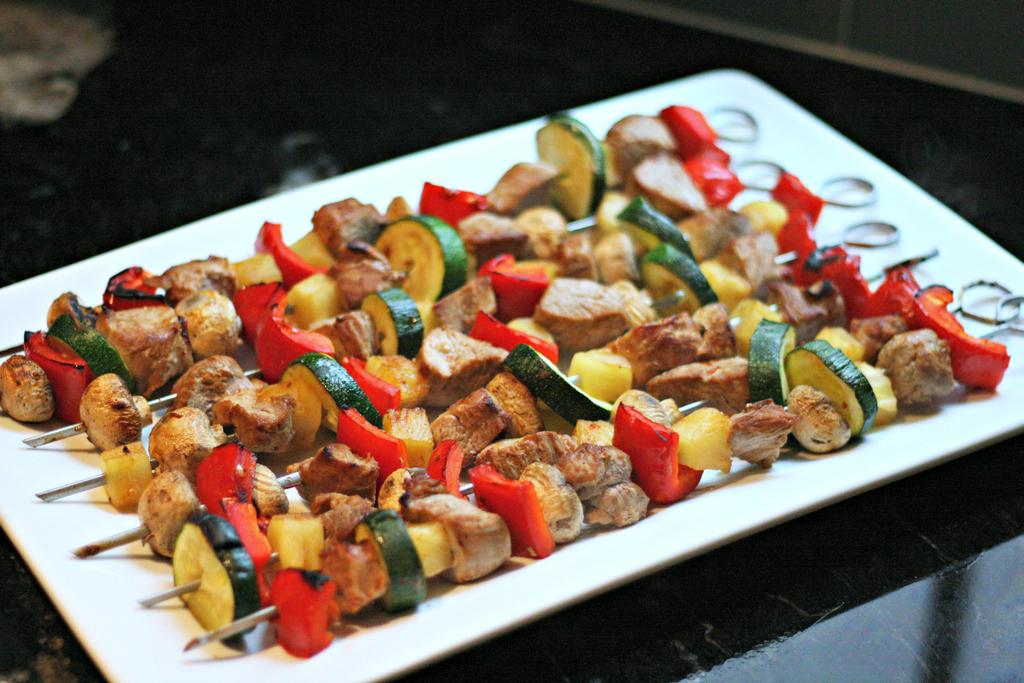What type of food is on the barbeque sticks in the image? The barbeque sticks in the image have veg items on them. Where are the veg barbeque sticks placed? The veg barbeque sticks are in a plate. On what surface is the plate located? The plate is on a table. What type of birds can be seen flying around the zebra in the image? There is no zebra or birds present in the image; it features veg barbeque sticks in a plate on a table. 